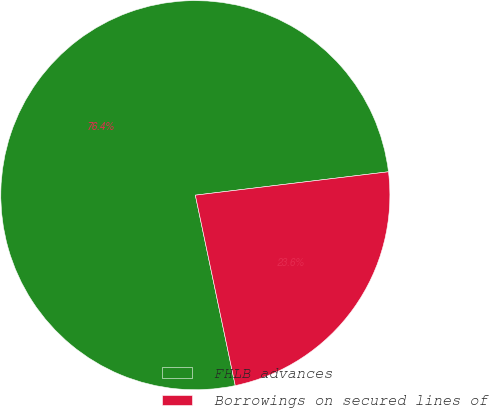Convert chart. <chart><loc_0><loc_0><loc_500><loc_500><pie_chart><fcel>FHLB advances<fcel>Borrowings on secured lines of<nl><fcel>76.37%<fcel>23.63%<nl></chart> 